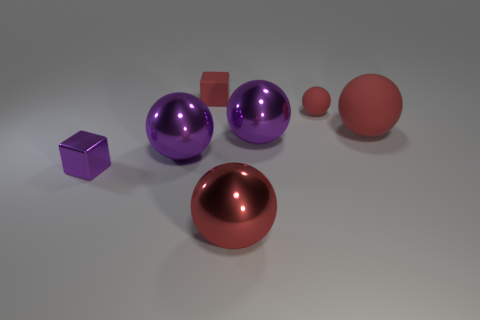Subtract all purple cylinders. How many red spheres are left? 3 Add 2 big metallic spheres. How many objects exist? 9 Subtract all purple balls. How many balls are left? 3 Subtract 2 spheres. How many spheres are left? 3 Subtract all purple metal balls. How many balls are left? 3 Subtract all cyan spheres. Subtract all purple cylinders. How many spheres are left? 5 Subtract all spheres. How many objects are left? 2 Subtract 0 gray cylinders. How many objects are left? 7 Subtract all big purple balls. Subtract all big matte balls. How many objects are left? 4 Add 3 matte spheres. How many matte spheres are left? 5 